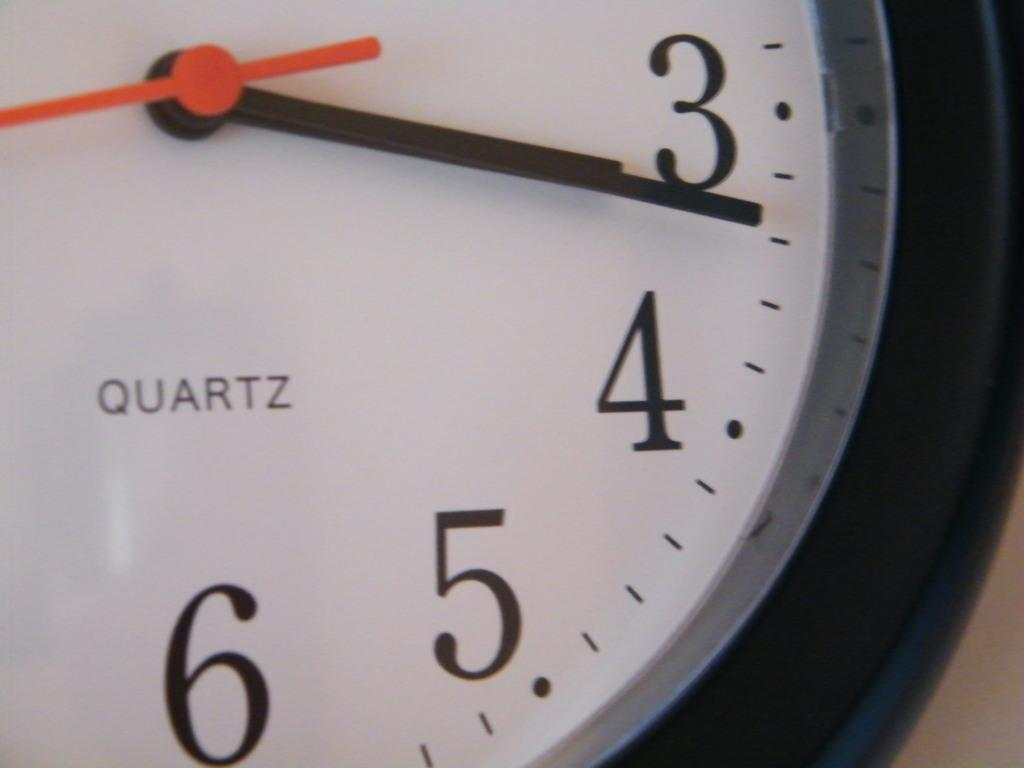<image>
Create a compact narrative representing the image presented. A clock with QUARTZ written on it shows the time as 3:17 